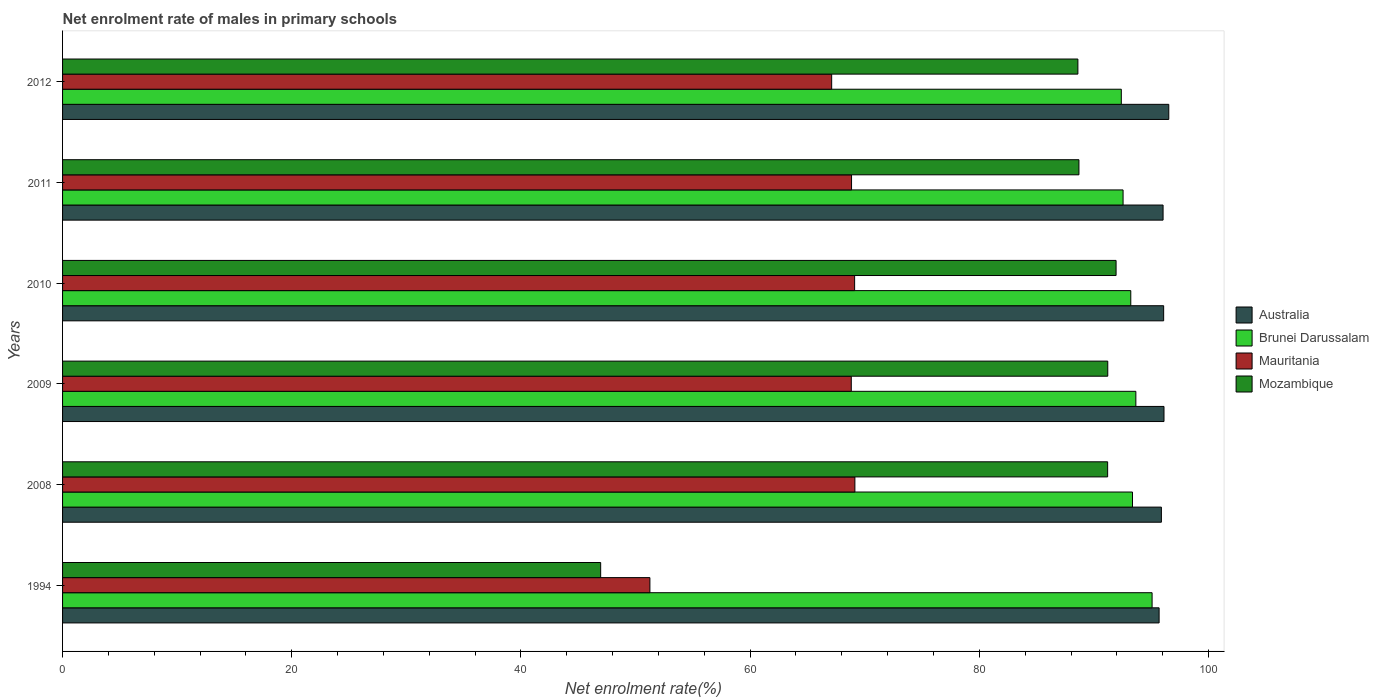How many different coloured bars are there?
Provide a succinct answer. 4. Are the number of bars on each tick of the Y-axis equal?
Make the answer very short. Yes. What is the label of the 6th group of bars from the top?
Ensure brevity in your answer.  1994. In how many cases, is the number of bars for a given year not equal to the number of legend labels?
Offer a terse response. 0. What is the net enrolment rate of males in primary schools in Mauritania in 2008?
Keep it short and to the point. 69.14. Across all years, what is the maximum net enrolment rate of males in primary schools in Mauritania?
Keep it short and to the point. 69.14. Across all years, what is the minimum net enrolment rate of males in primary schools in Australia?
Provide a succinct answer. 95.69. In which year was the net enrolment rate of males in primary schools in Mozambique minimum?
Give a very brief answer. 1994. What is the total net enrolment rate of males in primary schools in Brunei Darussalam in the graph?
Your answer should be very brief. 560.25. What is the difference between the net enrolment rate of males in primary schools in Mozambique in 2010 and that in 2012?
Your answer should be compact. 3.33. What is the difference between the net enrolment rate of males in primary schools in Brunei Darussalam in 2010 and the net enrolment rate of males in primary schools in Australia in 2009?
Provide a succinct answer. -2.9. What is the average net enrolment rate of males in primary schools in Brunei Darussalam per year?
Offer a terse response. 93.38. In the year 2009, what is the difference between the net enrolment rate of males in primary schools in Australia and net enrolment rate of males in primary schools in Brunei Darussalam?
Your answer should be very brief. 2.45. In how many years, is the net enrolment rate of males in primary schools in Mozambique greater than 4 %?
Offer a very short reply. 6. What is the ratio of the net enrolment rate of males in primary schools in Mozambique in 1994 to that in 2009?
Keep it short and to the point. 0.51. Is the net enrolment rate of males in primary schools in Brunei Darussalam in 2011 less than that in 2012?
Your answer should be compact. No. What is the difference between the highest and the second highest net enrolment rate of males in primary schools in Australia?
Your answer should be compact. 0.42. What is the difference between the highest and the lowest net enrolment rate of males in primary schools in Mozambique?
Your response must be concise. 44.98. In how many years, is the net enrolment rate of males in primary schools in Brunei Darussalam greater than the average net enrolment rate of males in primary schools in Brunei Darussalam taken over all years?
Offer a terse response. 2. Is it the case that in every year, the sum of the net enrolment rate of males in primary schools in Mauritania and net enrolment rate of males in primary schools in Mozambique is greater than the sum of net enrolment rate of males in primary schools in Australia and net enrolment rate of males in primary schools in Brunei Darussalam?
Your answer should be compact. No. Are all the bars in the graph horizontal?
Your response must be concise. Yes. How many years are there in the graph?
Offer a terse response. 6. Does the graph contain any zero values?
Provide a short and direct response. No. Does the graph contain grids?
Your answer should be very brief. No. How are the legend labels stacked?
Give a very brief answer. Vertical. What is the title of the graph?
Your answer should be very brief. Net enrolment rate of males in primary schools. What is the label or title of the X-axis?
Your answer should be very brief. Net enrolment rate(%). What is the Net enrolment rate(%) of Australia in 1994?
Offer a terse response. 95.69. What is the Net enrolment rate(%) of Brunei Darussalam in 1994?
Your answer should be very brief. 95.08. What is the Net enrolment rate(%) of Mauritania in 1994?
Provide a succinct answer. 51.25. What is the Net enrolment rate(%) of Mozambique in 1994?
Provide a short and direct response. 46.96. What is the Net enrolment rate(%) of Australia in 2008?
Your response must be concise. 95.89. What is the Net enrolment rate(%) in Brunei Darussalam in 2008?
Provide a short and direct response. 93.37. What is the Net enrolment rate(%) of Mauritania in 2008?
Your response must be concise. 69.14. What is the Net enrolment rate(%) of Mozambique in 2008?
Offer a very short reply. 91.2. What is the Net enrolment rate(%) of Australia in 2009?
Your answer should be very brief. 96.11. What is the Net enrolment rate(%) in Brunei Darussalam in 2009?
Your response must be concise. 93.66. What is the Net enrolment rate(%) of Mauritania in 2009?
Provide a succinct answer. 68.83. What is the Net enrolment rate(%) of Mozambique in 2009?
Give a very brief answer. 91.21. What is the Net enrolment rate(%) of Australia in 2010?
Your response must be concise. 96.09. What is the Net enrolment rate(%) of Brunei Darussalam in 2010?
Offer a terse response. 93.22. What is the Net enrolment rate(%) of Mauritania in 2010?
Provide a short and direct response. 69.12. What is the Net enrolment rate(%) of Mozambique in 2010?
Make the answer very short. 91.93. What is the Net enrolment rate(%) of Australia in 2011?
Make the answer very short. 96.03. What is the Net enrolment rate(%) in Brunei Darussalam in 2011?
Make the answer very short. 92.54. What is the Net enrolment rate(%) of Mauritania in 2011?
Give a very brief answer. 68.85. What is the Net enrolment rate(%) of Mozambique in 2011?
Your response must be concise. 88.69. What is the Net enrolment rate(%) of Australia in 2012?
Your answer should be very brief. 96.53. What is the Net enrolment rate(%) in Brunei Darussalam in 2012?
Offer a very short reply. 92.39. What is the Net enrolment rate(%) in Mauritania in 2012?
Your response must be concise. 67.12. What is the Net enrolment rate(%) in Mozambique in 2012?
Offer a terse response. 88.6. Across all years, what is the maximum Net enrolment rate(%) in Australia?
Give a very brief answer. 96.53. Across all years, what is the maximum Net enrolment rate(%) of Brunei Darussalam?
Your answer should be compact. 95.08. Across all years, what is the maximum Net enrolment rate(%) of Mauritania?
Keep it short and to the point. 69.14. Across all years, what is the maximum Net enrolment rate(%) in Mozambique?
Your answer should be compact. 91.93. Across all years, what is the minimum Net enrolment rate(%) of Australia?
Keep it short and to the point. 95.69. Across all years, what is the minimum Net enrolment rate(%) of Brunei Darussalam?
Offer a very short reply. 92.39. Across all years, what is the minimum Net enrolment rate(%) in Mauritania?
Provide a succinct answer. 51.25. Across all years, what is the minimum Net enrolment rate(%) in Mozambique?
Offer a terse response. 46.96. What is the total Net enrolment rate(%) in Australia in the graph?
Make the answer very short. 576.34. What is the total Net enrolment rate(%) of Brunei Darussalam in the graph?
Keep it short and to the point. 560.25. What is the total Net enrolment rate(%) of Mauritania in the graph?
Offer a very short reply. 394.3. What is the total Net enrolment rate(%) in Mozambique in the graph?
Offer a very short reply. 498.59. What is the difference between the Net enrolment rate(%) in Australia in 1994 and that in 2008?
Provide a succinct answer. -0.2. What is the difference between the Net enrolment rate(%) in Brunei Darussalam in 1994 and that in 2008?
Provide a succinct answer. 1.71. What is the difference between the Net enrolment rate(%) of Mauritania in 1994 and that in 2008?
Make the answer very short. -17.89. What is the difference between the Net enrolment rate(%) in Mozambique in 1994 and that in 2008?
Offer a very short reply. -44.24. What is the difference between the Net enrolment rate(%) of Australia in 1994 and that in 2009?
Offer a terse response. -0.43. What is the difference between the Net enrolment rate(%) of Brunei Darussalam in 1994 and that in 2009?
Your answer should be very brief. 1.42. What is the difference between the Net enrolment rate(%) in Mauritania in 1994 and that in 2009?
Give a very brief answer. -17.57. What is the difference between the Net enrolment rate(%) in Mozambique in 1994 and that in 2009?
Provide a short and direct response. -44.25. What is the difference between the Net enrolment rate(%) in Australia in 1994 and that in 2010?
Give a very brief answer. -0.4. What is the difference between the Net enrolment rate(%) in Brunei Darussalam in 1994 and that in 2010?
Make the answer very short. 1.86. What is the difference between the Net enrolment rate(%) in Mauritania in 1994 and that in 2010?
Offer a very short reply. -17.86. What is the difference between the Net enrolment rate(%) in Mozambique in 1994 and that in 2010?
Make the answer very short. -44.98. What is the difference between the Net enrolment rate(%) in Australia in 1994 and that in 2011?
Provide a succinct answer. -0.35. What is the difference between the Net enrolment rate(%) of Brunei Darussalam in 1994 and that in 2011?
Your answer should be compact. 2.53. What is the difference between the Net enrolment rate(%) in Mauritania in 1994 and that in 2011?
Make the answer very short. -17.6. What is the difference between the Net enrolment rate(%) of Mozambique in 1994 and that in 2011?
Keep it short and to the point. -41.73. What is the difference between the Net enrolment rate(%) of Australia in 1994 and that in 2012?
Provide a short and direct response. -0.84. What is the difference between the Net enrolment rate(%) in Brunei Darussalam in 1994 and that in 2012?
Ensure brevity in your answer.  2.69. What is the difference between the Net enrolment rate(%) of Mauritania in 1994 and that in 2012?
Offer a very short reply. -15.86. What is the difference between the Net enrolment rate(%) in Mozambique in 1994 and that in 2012?
Offer a very short reply. -41.64. What is the difference between the Net enrolment rate(%) in Australia in 2008 and that in 2009?
Offer a very short reply. -0.23. What is the difference between the Net enrolment rate(%) of Brunei Darussalam in 2008 and that in 2009?
Provide a succinct answer. -0.29. What is the difference between the Net enrolment rate(%) of Mauritania in 2008 and that in 2009?
Your response must be concise. 0.31. What is the difference between the Net enrolment rate(%) of Mozambique in 2008 and that in 2009?
Your response must be concise. -0.01. What is the difference between the Net enrolment rate(%) of Australia in 2008 and that in 2010?
Ensure brevity in your answer.  -0.2. What is the difference between the Net enrolment rate(%) of Brunei Darussalam in 2008 and that in 2010?
Provide a succinct answer. 0.15. What is the difference between the Net enrolment rate(%) in Mauritania in 2008 and that in 2010?
Make the answer very short. 0.02. What is the difference between the Net enrolment rate(%) in Mozambique in 2008 and that in 2010?
Offer a very short reply. -0.74. What is the difference between the Net enrolment rate(%) of Australia in 2008 and that in 2011?
Offer a very short reply. -0.15. What is the difference between the Net enrolment rate(%) of Brunei Darussalam in 2008 and that in 2011?
Ensure brevity in your answer.  0.82. What is the difference between the Net enrolment rate(%) of Mauritania in 2008 and that in 2011?
Offer a terse response. 0.29. What is the difference between the Net enrolment rate(%) of Mozambique in 2008 and that in 2011?
Your answer should be compact. 2.51. What is the difference between the Net enrolment rate(%) in Australia in 2008 and that in 2012?
Provide a succinct answer. -0.64. What is the difference between the Net enrolment rate(%) of Brunei Darussalam in 2008 and that in 2012?
Your answer should be compact. 0.98. What is the difference between the Net enrolment rate(%) of Mauritania in 2008 and that in 2012?
Give a very brief answer. 2.03. What is the difference between the Net enrolment rate(%) of Mozambique in 2008 and that in 2012?
Your response must be concise. 2.6. What is the difference between the Net enrolment rate(%) of Australia in 2009 and that in 2010?
Your answer should be compact. 0.03. What is the difference between the Net enrolment rate(%) in Brunei Darussalam in 2009 and that in 2010?
Your answer should be very brief. 0.44. What is the difference between the Net enrolment rate(%) in Mauritania in 2009 and that in 2010?
Ensure brevity in your answer.  -0.29. What is the difference between the Net enrolment rate(%) of Mozambique in 2009 and that in 2010?
Your answer should be compact. -0.73. What is the difference between the Net enrolment rate(%) of Australia in 2009 and that in 2011?
Your answer should be compact. 0.08. What is the difference between the Net enrolment rate(%) of Brunei Darussalam in 2009 and that in 2011?
Provide a succinct answer. 1.12. What is the difference between the Net enrolment rate(%) in Mauritania in 2009 and that in 2011?
Ensure brevity in your answer.  -0.02. What is the difference between the Net enrolment rate(%) in Mozambique in 2009 and that in 2011?
Provide a short and direct response. 2.52. What is the difference between the Net enrolment rate(%) of Australia in 2009 and that in 2012?
Keep it short and to the point. -0.42. What is the difference between the Net enrolment rate(%) of Brunei Darussalam in 2009 and that in 2012?
Offer a very short reply. 1.27. What is the difference between the Net enrolment rate(%) of Mauritania in 2009 and that in 2012?
Provide a succinct answer. 1.71. What is the difference between the Net enrolment rate(%) in Mozambique in 2009 and that in 2012?
Give a very brief answer. 2.61. What is the difference between the Net enrolment rate(%) in Australia in 2010 and that in 2011?
Your response must be concise. 0.05. What is the difference between the Net enrolment rate(%) in Brunei Darussalam in 2010 and that in 2011?
Offer a very short reply. 0.67. What is the difference between the Net enrolment rate(%) of Mauritania in 2010 and that in 2011?
Make the answer very short. 0.27. What is the difference between the Net enrolment rate(%) of Mozambique in 2010 and that in 2011?
Give a very brief answer. 3.24. What is the difference between the Net enrolment rate(%) in Australia in 2010 and that in 2012?
Provide a short and direct response. -0.45. What is the difference between the Net enrolment rate(%) in Brunei Darussalam in 2010 and that in 2012?
Your answer should be very brief. 0.83. What is the difference between the Net enrolment rate(%) of Mauritania in 2010 and that in 2012?
Give a very brief answer. 2. What is the difference between the Net enrolment rate(%) in Mozambique in 2010 and that in 2012?
Offer a very short reply. 3.33. What is the difference between the Net enrolment rate(%) of Australia in 2011 and that in 2012?
Give a very brief answer. -0.5. What is the difference between the Net enrolment rate(%) of Brunei Darussalam in 2011 and that in 2012?
Your answer should be compact. 0.15. What is the difference between the Net enrolment rate(%) of Mauritania in 2011 and that in 2012?
Offer a very short reply. 1.73. What is the difference between the Net enrolment rate(%) of Mozambique in 2011 and that in 2012?
Provide a succinct answer. 0.09. What is the difference between the Net enrolment rate(%) of Australia in 1994 and the Net enrolment rate(%) of Brunei Darussalam in 2008?
Keep it short and to the point. 2.32. What is the difference between the Net enrolment rate(%) of Australia in 1994 and the Net enrolment rate(%) of Mauritania in 2008?
Give a very brief answer. 26.55. What is the difference between the Net enrolment rate(%) of Australia in 1994 and the Net enrolment rate(%) of Mozambique in 2008?
Give a very brief answer. 4.49. What is the difference between the Net enrolment rate(%) in Brunei Darussalam in 1994 and the Net enrolment rate(%) in Mauritania in 2008?
Keep it short and to the point. 25.94. What is the difference between the Net enrolment rate(%) in Brunei Darussalam in 1994 and the Net enrolment rate(%) in Mozambique in 2008?
Offer a very short reply. 3.88. What is the difference between the Net enrolment rate(%) of Mauritania in 1994 and the Net enrolment rate(%) of Mozambique in 2008?
Ensure brevity in your answer.  -39.94. What is the difference between the Net enrolment rate(%) of Australia in 1994 and the Net enrolment rate(%) of Brunei Darussalam in 2009?
Ensure brevity in your answer.  2.03. What is the difference between the Net enrolment rate(%) of Australia in 1994 and the Net enrolment rate(%) of Mauritania in 2009?
Give a very brief answer. 26.86. What is the difference between the Net enrolment rate(%) of Australia in 1994 and the Net enrolment rate(%) of Mozambique in 2009?
Offer a very short reply. 4.48. What is the difference between the Net enrolment rate(%) in Brunei Darussalam in 1994 and the Net enrolment rate(%) in Mauritania in 2009?
Make the answer very short. 26.25. What is the difference between the Net enrolment rate(%) in Brunei Darussalam in 1994 and the Net enrolment rate(%) in Mozambique in 2009?
Keep it short and to the point. 3.87. What is the difference between the Net enrolment rate(%) of Mauritania in 1994 and the Net enrolment rate(%) of Mozambique in 2009?
Provide a short and direct response. -39.95. What is the difference between the Net enrolment rate(%) in Australia in 1994 and the Net enrolment rate(%) in Brunei Darussalam in 2010?
Provide a short and direct response. 2.47. What is the difference between the Net enrolment rate(%) of Australia in 1994 and the Net enrolment rate(%) of Mauritania in 2010?
Provide a short and direct response. 26.57. What is the difference between the Net enrolment rate(%) of Australia in 1994 and the Net enrolment rate(%) of Mozambique in 2010?
Ensure brevity in your answer.  3.76. What is the difference between the Net enrolment rate(%) of Brunei Darussalam in 1994 and the Net enrolment rate(%) of Mauritania in 2010?
Your response must be concise. 25.96. What is the difference between the Net enrolment rate(%) in Brunei Darussalam in 1994 and the Net enrolment rate(%) in Mozambique in 2010?
Ensure brevity in your answer.  3.14. What is the difference between the Net enrolment rate(%) in Mauritania in 1994 and the Net enrolment rate(%) in Mozambique in 2010?
Offer a terse response. -40.68. What is the difference between the Net enrolment rate(%) in Australia in 1994 and the Net enrolment rate(%) in Brunei Darussalam in 2011?
Ensure brevity in your answer.  3.15. What is the difference between the Net enrolment rate(%) of Australia in 1994 and the Net enrolment rate(%) of Mauritania in 2011?
Give a very brief answer. 26.84. What is the difference between the Net enrolment rate(%) of Australia in 1994 and the Net enrolment rate(%) of Mozambique in 2011?
Offer a very short reply. 7. What is the difference between the Net enrolment rate(%) in Brunei Darussalam in 1994 and the Net enrolment rate(%) in Mauritania in 2011?
Your response must be concise. 26.23. What is the difference between the Net enrolment rate(%) in Brunei Darussalam in 1994 and the Net enrolment rate(%) in Mozambique in 2011?
Your answer should be compact. 6.38. What is the difference between the Net enrolment rate(%) of Mauritania in 1994 and the Net enrolment rate(%) of Mozambique in 2011?
Your answer should be very brief. -37.44. What is the difference between the Net enrolment rate(%) in Australia in 1994 and the Net enrolment rate(%) in Brunei Darussalam in 2012?
Give a very brief answer. 3.3. What is the difference between the Net enrolment rate(%) in Australia in 1994 and the Net enrolment rate(%) in Mauritania in 2012?
Your answer should be compact. 28.57. What is the difference between the Net enrolment rate(%) of Australia in 1994 and the Net enrolment rate(%) of Mozambique in 2012?
Your answer should be compact. 7.09. What is the difference between the Net enrolment rate(%) of Brunei Darussalam in 1994 and the Net enrolment rate(%) of Mauritania in 2012?
Offer a very short reply. 27.96. What is the difference between the Net enrolment rate(%) of Brunei Darussalam in 1994 and the Net enrolment rate(%) of Mozambique in 2012?
Give a very brief answer. 6.47. What is the difference between the Net enrolment rate(%) of Mauritania in 1994 and the Net enrolment rate(%) of Mozambique in 2012?
Offer a terse response. -37.35. What is the difference between the Net enrolment rate(%) of Australia in 2008 and the Net enrolment rate(%) of Brunei Darussalam in 2009?
Provide a short and direct response. 2.23. What is the difference between the Net enrolment rate(%) in Australia in 2008 and the Net enrolment rate(%) in Mauritania in 2009?
Provide a succinct answer. 27.06. What is the difference between the Net enrolment rate(%) in Australia in 2008 and the Net enrolment rate(%) in Mozambique in 2009?
Provide a short and direct response. 4.68. What is the difference between the Net enrolment rate(%) of Brunei Darussalam in 2008 and the Net enrolment rate(%) of Mauritania in 2009?
Offer a very short reply. 24.54. What is the difference between the Net enrolment rate(%) in Brunei Darussalam in 2008 and the Net enrolment rate(%) in Mozambique in 2009?
Make the answer very short. 2.16. What is the difference between the Net enrolment rate(%) of Mauritania in 2008 and the Net enrolment rate(%) of Mozambique in 2009?
Ensure brevity in your answer.  -22.07. What is the difference between the Net enrolment rate(%) of Australia in 2008 and the Net enrolment rate(%) of Brunei Darussalam in 2010?
Provide a short and direct response. 2.67. What is the difference between the Net enrolment rate(%) of Australia in 2008 and the Net enrolment rate(%) of Mauritania in 2010?
Your response must be concise. 26.77. What is the difference between the Net enrolment rate(%) in Australia in 2008 and the Net enrolment rate(%) in Mozambique in 2010?
Ensure brevity in your answer.  3.95. What is the difference between the Net enrolment rate(%) of Brunei Darussalam in 2008 and the Net enrolment rate(%) of Mauritania in 2010?
Offer a very short reply. 24.25. What is the difference between the Net enrolment rate(%) of Brunei Darussalam in 2008 and the Net enrolment rate(%) of Mozambique in 2010?
Ensure brevity in your answer.  1.43. What is the difference between the Net enrolment rate(%) in Mauritania in 2008 and the Net enrolment rate(%) in Mozambique in 2010?
Provide a short and direct response. -22.79. What is the difference between the Net enrolment rate(%) in Australia in 2008 and the Net enrolment rate(%) in Brunei Darussalam in 2011?
Your answer should be compact. 3.34. What is the difference between the Net enrolment rate(%) in Australia in 2008 and the Net enrolment rate(%) in Mauritania in 2011?
Your answer should be compact. 27.04. What is the difference between the Net enrolment rate(%) in Australia in 2008 and the Net enrolment rate(%) in Mozambique in 2011?
Make the answer very short. 7.2. What is the difference between the Net enrolment rate(%) in Brunei Darussalam in 2008 and the Net enrolment rate(%) in Mauritania in 2011?
Offer a terse response. 24.52. What is the difference between the Net enrolment rate(%) of Brunei Darussalam in 2008 and the Net enrolment rate(%) of Mozambique in 2011?
Give a very brief answer. 4.68. What is the difference between the Net enrolment rate(%) in Mauritania in 2008 and the Net enrolment rate(%) in Mozambique in 2011?
Keep it short and to the point. -19.55. What is the difference between the Net enrolment rate(%) of Australia in 2008 and the Net enrolment rate(%) of Brunei Darussalam in 2012?
Offer a terse response. 3.5. What is the difference between the Net enrolment rate(%) in Australia in 2008 and the Net enrolment rate(%) in Mauritania in 2012?
Offer a very short reply. 28.77. What is the difference between the Net enrolment rate(%) of Australia in 2008 and the Net enrolment rate(%) of Mozambique in 2012?
Keep it short and to the point. 7.29. What is the difference between the Net enrolment rate(%) of Brunei Darussalam in 2008 and the Net enrolment rate(%) of Mauritania in 2012?
Keep it short and to the point. 26.25. What is the difference between the Net enrolment rate(%) of Brunei Darussalam in 2008 and the Net enrolment rate(%) of Mozambique in 2012?
Provide a succinct answer. 4.77. What is the difference between the Net enrolment rate(%) in Mauritania in 2008 and the Net enrolment rate(%) in Mozambique in 2012?
Keep it short and to the point. -19.46. What is the difference between the Net enrolment rate(%) of Australia in 2009 and the Net enrolment rate(%) of Brunei Darussalam in 2010?
Your response must be concise. 2.9. What is the difference between the Net enrolment rate(%) of Australia in 2009 and the Net enrolment rate(%) of Mauritania in 2010?
Provide a succinct answer. 27. What is the difference between the Net enrolment rate(%) in Australia in 2009 and the Net enrolment rate(%) in Mozambique in 2010?
Your answer should be compact. 4.18. What is the difference between the Net enrolment rate(%) in Brunei Darussalam in 2009 and the Net enrolment rate(%) in Mauritania in 2010?
Offer a very short reply. 24.54. What is the difference between the Net enrolment rate(%) of Brunei Darussalam in 2009 and the Net enrolment rate(%) of Mozambique in 2010?
Your answer should be compact. 1.73. What is the difference between the Net enrolment rate(%) in Mauritania in 2009 and the Net enrolment rate(%) in Mozambique in 2010?
Provide a succinct answer. -23.11. What is the difference between the Net enrolment rate(%) of Australia in 2009 and the Net enrolment rate(%) of Brunei Darussalam in 2011?
Offer a terse response. 3.57. What is the difference between the Net enrolment rate(%) in Australia in 2009 and the Net enrolment rate(%) in Mauritania in 2011?
Offer a very short reply. 27.27. What is the difference between the Net enrolment rate(%) in Australia in 2009 and the Net enrolment rate(%) in Mozambique in 2011?
Make the answer very short. 7.42. What is the difference between the Net enrolment rate(%) of Brunei Darussalam in 2009 and the Net enrolment rate(%) of Mauritania in 2011?
Your answer should be compact. 24.81. What is the difference between the Net enrolment rate(%) of Brunei Darussalam in 2009 and the Net enrolment rate(%) of Mozambique in 2011?
Offer a terse response. 4.97. What is the difference between the Net enrolment rate(%) in Mauritania in 2009 and the Net enrolment rate(%) in Mozambique in 2011?
Make the answer very short. -19.87. What is the difference between the Net enrolment rate(%) in Australia in 2009 and the Net enrolment rate(%) in Brunei Darussalam in 2012?
Offer a very short reply. 3.72. What is the difference between the Net enrolment rate(%) of Australia in 2009 and the Net enrolment rate(%) of Mauritania in 2012?
Give a very brief answer. 29. What is the difference between the Net enrolment rate(%) of Australia in 2009 and the Net enrolment rate(%) of Mozambique in 2012?
Keep it short and to the point. 7.51. What is the difference between the Net enrolment rate(%) in Brunei Darussalam in 2009 and the Net enrolment rate(%) in Mauritania in 2012?
Your response must be concise. 26.54. What is the difference between the Net enrolment rate(%) of Brunei Darussalam in 2009 and the Net enrolment rate(%) of Mozambique in 2012?
Offer a very short reply. 5.06. What is the difference between the Net enrolment rate(%) of Mauritania in 2009 and the Net enrolment rate(%) of Mozambique in 2012?
Offer a very short reply. -19.77. What is the difference between the Net enrolment rate(%) in Australia in 2010 and the Net enrolment rate(%) in Brunei Darussalam in 2011?
Make the answer very short. 3.54. What is the difference between the Net enrolment rate(%) in Australia in 2010 and the Net enrolment rate(%) in Mauritania in 2011?
Provide a short and direct response. 27.24. What is the difference between the Net enrolment rate(%) in Australia in 2010 and the Net enrolment rate(%) in Mozambique in 2011?
Offer a terse response. 7.39. What is the difference between the Net enrolment rate(%) of Brunei Darussalam in 2010 and the Net enrolment rate(%) of Mauritania in 2011?
Your answer should be very brief. 24.37. What is the difference between the Net enrolment rate(%) of Brunei Darussalam in 2010 and the Net enrolment rate(%) of Mozambique in 2011?
Keep it short and to the point. 4.52. What is the difference between the Net enrolment rate(%) in Mauritania in 2010 and the Net enrolment rate(%) in Mozambique in 2011?
Keep it short and to the point. -19.57. What is the difference between the Net enrolment rate(%) in Australia in 2010 and the Net enrolment rate(%) in Brunei Darussalam in 2012?
Provide a short and direct response. 3.69. What is the difference between the Net enrolment rate(%) of Australia in 2010 and the Net enrolment rate(%) of Mauritania in 2012?
Your response must be concise. 28.97. What is the difference between the Net enrolment rate(%) of Australia in 2010 and the Net enrolment rate(%) of Mozambique in 2012?
Make the answer very short. 7.48. What is the difference between the Net enrolment rate(%) of Brunei Darussalam in 2010 and the Net enrolment rate(%) of Mauritania in 2012?
Provide a succinct answer. 26.1. What is the difference between the Net enrolment rate(%) in Brunei Darussalam in 2010 and the Net enrolment rate(%) in Mozambique in 2012?
Give a very brief answer. 4.62. What is the difference between the Net enrolment rate(%) in Mauritania in 2010 and the Net enrolment rate(%) in Mozambique in 2012?
Keep it short and to the point. -19.48. What is the difference between the Net enrolment rate(%) in Australia in 2011 and the Net enrolment rate(%) in Brunei Darussalam in 2012?
Your answer should be compact. 3.64. What is the difference between the Net enrolment rate(%) of Australia in 2011 and the Net enrolment rate(%) of Mauritania in 2012?
Ensure brevity in your answer.  28.92. What is the difference between the Net enrolment rate(%) of Australia in 2011 and the Net enrolment rate(%) of Mozambique in 2012?
Your answer should be compact. 7.43. What is the difference between the Net enrolment rate(%) in Brunei Darussalam in 2011 and the Net enrolment rate(%) in Mauritania in 2012?
Give a very brief answer. 25.43. What is the difference between the Net enrolment rate(%) of Brunei Darussalam in 2011 and the Net enrolment rate(%) of Mozambique in 2012?
Your answer should be compact. 3.94. What is the difference between the Net enrolment rate(%) in Mauritania in 2011 and the Net enrolment rate(%) in Mozambique in 2012?
Your response must be concise. -19.75. What is the average Net enrolment rate(%) of Australia per year?
Give a very brief answer. 96.06. What is the average Net enrolment rate(%) of Brunei Darussalam per year?
Provide a short and direct response. 93.38. What is the average Net enrolment rate(%) in Mauritania per year?
Ensure brevity in your answer.  65.72. What is the average Net enrolment rate(%) of Mozambique per year?
Your response must be concise. 83.1. In the year 1994, what is the difference between the Net enrolment rate(%) of Australia and Net enrolment rate(%) of Brunei Darussalam?
Make the answer very short. 0.61. In the year 1994, what is the difference between the Net enrolment rate(%) in Australia and Net enrolment rate(%) in Mauritania?
Give a very brief answer. 44.43. In the year 1994, what is the difference between the Net enrolment rate(%) in Australia and Net enrolment rate(%) in Mozambique?
Provide a short and direct response. 48.73. In the year 1994, what is the difference between the Net enrolment rate(%) of Brunei Darussalam and Net enrolment rate(%) of Mauritania?
Ensure brevity in your answer.  43.82. In the year 1994, what is the difference between the Net enrolment rate(%) of Brunei Darussalam and Net enrolment rate(%) of Mozambique?
Provide a short and direct response. 48.12. In the year 1994, what is the difference between the Net enrolment rate(%) of Mauritania and Net enrolment rate(%) of Mozambique?
Offer a terse response. 4.3. In the year 2008, what is the difference between the Net enrolment rate(%) in Australia and Net enrolment rate(%) in Brunei Darussalam?
Offer a terse response. 2.52. In the year 2008, what is the difference between the Net enrolment rate(%) in Australia and Net enrolment rate(%) in Mauritania?
Keep it short and to the point. 26.75. In the year 2008, what is the difference between the Net enrolment rate(%) in Australia and Net enrolment rate(%) in Mozambique?
Ensure brevity in your answer.  4.69. In the year 2008, what is the difference between the Net enrolment rate(%) of Brunei Darussalam and Net enrolment rate(%) of Mauritania?
Offer a very short reply. 24.23. In the year 2008, what is the difference between the Net enrolment rate(%) in Brunei Darussalam and Net enrolment rate(%) in Mozambique?
Your answer should be compact. 2.17. In the year 2008, what is the difference between the Net enrolment rate(%) of Mauritania and Net enrolment rate(%) of Mozambique?
Give a very brief answer. -22.06. In the year 2009, what is the difference between the Net enrolment rate(%) in Australia and Net enrolment rate(%) in Brunei Darussalam?
Your answer should be very brief. 2.45. In the year 2009, what is the difference between the Net enrolment rate(%) in Australia and Net enrolment rate(%) in Mauritania?
Provide a short and direct response. 27.29. In the year 2009, what is the difference between the Net enrolment rate(%) in Australia and Net enrolment rate(%) in Mozambique?
Make the answer very short. 4.91. In the year 2009, what is the difference between the Net enrolment rate(%) of Brunei Darussalam and Net enrolment rate(%) of Mauritania?
Provide a succinct answer. 24.83. In the year 2009, what is the difference between the Net enrolment rate(%) of Brunei Darussalam and Net enrolment rate(%) of Mozambique?
Ensure brevity in your answer.  2.45. In the year 2009, what is the difference between the Net enrolment rate(%) in Mauritania and Net enrolment rate(%) in Mozambique?
Offer a very short reply. -22.38. In the year 2010, what is the difference between the Net enrolment rate(%) of Australia and Net enrolment rate(%) of Brunei Darussalam?
Provide a succinct answer. 2.87. In the year 2010, what is the difference between the Net enrolment rate(%) in Australia and Net enrolment rate(%) in Mauritania?
Your answer should be compact. 26.97. In the year 2010, what is the difference between the Net enrolment rate(%) of Australia and Net enrolment rate(%) of Mozambique?
Offer a very short reply. 4.15. In the year 2010, what is the difference between the Net enrolment rate(%) in Brunei Darussalam and Net enrolment rate(%) in Mauritania?
Your answer should be compact. 24.1. In the year 2010, what is the difference between the Net enrolment rate(%) of Brunei Darussalam and Net enrolment rate(%) of Mozambique?
Provide a succinct answer. 1.28. In the year 2010, what is the difference between the Net enrolment rate(%) in Mauritania and Net enrolment rate(%) in Mozambique?
Offer a terse response. -22.82. In the year 2011, what is the difference between the Net enrolment rate(%) in Australia and Net enrolment rate(%) in Brunei Darussalam?
Keep it short and to the point. 3.49. In the year 2011, what is the difference between the Net enrolment rate(%) in Australia and Net enrolment rate(%) in Mauritania?
Offer a very short reply. 27.18. In the year 2011, what is the difference between the Net enrolment rate(%) of Australia and Net enrolment rate(%) of Mozambique?
Your response must be concise. 7.34. In the year 2011, what is the difference between the Net enrolment rate(%) in Brunei Darussalam and Net enrolment rate(%) in Mauritania?
Your answer should be very brief. 23.69. In the year 2011, what is the difference between the Net enrolment rate(%) of Brunei Darussalam and Net enrolment rate(%) of Mozambique?
Offer a very short reply. 3.85. In the year 2011, what is the difference between the Net enrolment rate(%) of Mauritania and Net enrolment rate(%) of Mozambique?
Offer a terse response. -19.84. In the year 2012, what is the difference between the Net enrolment rate(%) in Australia and Net enrolment rate(%) in Brunei Darussalam?
Offer a very short reply. 4.14. In the year 2012, what is the difference between the Net enrolment rate(%) of Australia and Net enrolment rate(%) of Mauritania?
Your answer should be very brief. 29.42. In the year 2012, what is the difference between the Net enrolment rate(%) of Australia and Net enrolment rate(%) of Mozambique?
Your answer should be compact. 7.93. In the year 2012, what is the difference between the Net enrolment rate(%) of Brunei Darussalam and Net enrolment rate(%) of Mauritania?
Ensure brevity in your answer.  25.28. In the year 2012, what is the difference between the Net enrolment rate(%) of Brunei Darussalam and Net enrolment rate(%) of Mozambique?
Keep it short and to the point. 3.79. In the year 2012, what is the difference between the Net enrolment rate(%) in Mauritania and Net enrolment rate(%) in Mozambique?
Your answer should be very brief. -21.49. What is the ratio of the Net enrolment rate(%) of Brunei Darussalam in 1994 to that in 2008?
Give a very brief answer. 1.02. What is the ratio of the Net enrolment rate(%) of Mauritania in 1994 to that in 2008?
Offer a very short reply. 0.74. What is the ratio of the Net enrolment rate(%) in Mozambique in 1994 to that in 2008?
Offer a terse response. 0.51. What is the ratio of the Net enrolment rate(%) in Brunei Darussalam in 1994 to that in 2009?
Keep it short and to the point. 1.02. What is the ratio of the Net enrolment rate(%) of Mauritania in 1994 to that in 2009?
Your response must be concise. 0.74. What is the ratio of the Net enrolment rate(%) of Mozambique in 1994 to that in 2009?
Provide a short and direct response. 0.51. What is the ratio of the Net enrolment rate(%) of Brunei Darussalam in 1994 to that in 2010?
Offer a terse response. 1.02. What is the ratio of the Net enrolment rate(%) in Mauritania in 1994 to that in 2010?
Offer a terse response. 0.74. What is the ratio of the Net enrolment rate(%) in Mozambique in 1994 to that in 2010?
Your response must be concise. 0.51. What is the ratio of the Net enrolment rate(%) of Brunei Darussalam in 1994 to that in 2011?
Your answer should be very brief. 1.03. What is the ratio of the Net enrolment rate(%) in Mauritania in 1994 to that in 2011?
Keep it short and to the point. 0.74. What is the ratio of the Net enrolment rate(%) in Mozambique in 1994 to that in 2011?
Provide a succinct answer. 0.53. What is the ratio of the Net enrolment rate(%) of Australia in 1994 to that in 2012?
Make the answer very short. 0.99. What is the ratio of the Net enrolment rate(%) of Brunei Darussalam in 1994 to that in 2012?
Ensure brevity in your answer.  1.03. What is the ratio of the Net enrolment rate(%) in Mauritania in 1994 to that in 2012?
Your answer should be very brief. 0.76. What is the ratio of the Net enrolment rate(%) in Mozambique in 1994 to that in 2012?
Your answer should be compact. 0.53. What is the ratio of the Net enrolment rate(%) of Australia in 2008 to that in 2009?
Your answer should be very brief. 1. What is the ratio of the Net enrolment rate(%) of Mozambique in 2008 to that in 2009?
Ensure brevity in your answer.  1. What is the ratio of the Net enrolment rate(%) of Australia in 2008 to that in 2010?
Your answer should be compact. 1. What is the ratio of the Net enrolment rate(%) of Brunei Darussalam in 2008 to that in 2010?
Offer a very short reply. 1. What is the ratio of the Net enrolment rate(%) of Mozambique in 2008 to that in 2010?
Give a very brief answer. 0.99. What is the ratio of the Net enrolment rate(%) in Brunei Darussalam in 2008 to that in 2011?
Make the answer very short. 1.01. What is the ratio of the Net enrolment rate(%) in Mauritania in 2008 to that in 2011?
Offer a terse response. 1. What is the ratio of the Net enrolment rate(%) in Mozambique in 2008 to that in 2011?
Your answer should be very brief. 1.03. What is the ratio of the Net enrolment rate(%) in Australia in 2008 to that in 2012?
Provide a short and direct response. 0.99. What is the ratio of the Net enrolment rate(%) in Brunei Darussalam in 2008 to that in 2012?
Ensure brevity in your answer.  1.01. What is the ratio of the Net enrolment rate(%) in Mauritania in 2008 to that in 2012?
Your answer should be very brief. 1.03. What is the ratio of the Net enrolment rate(%) in Mozambique in 2008 to that in 2012?
Offer a terse response. 1.03. What is the ratio of the Net enrolment rate(%) of Brunei Darussalam in 2009 to that in 2011?
Provide a short and direct response. 1.01. What is the ratio of the Net enrolment rate(%) in Mauritania in 2009 to that in 2011?
Offer a very short reply. 1. What is the ratio of the Net enrolment rate(%) in Mozambique in 2009 to that in 2011?
Your answer should be compact. 1.03. What is the ratio of the Net enrolment rate(%) of Brunei Darussalam in 2009 to that in 2012?
Make the answer very short. 1.01. What is the ratio of the Net enrolment rate(%) of Mauritania in 2009 to that in 2012?
Your response must be concise. 1.03. What is the ratio of the Net enrolment rate(%) of Mozambique in 2009 to that in 2012?
Your answer should be very brief. 1.03. What is the ratio of the Net enrolment rate(%) in Australia in 2010 to that in 2011?
Provide a short and direct response. 1. What is the ratio of the Net enrolment rate(%) of Brunei Darussalam in 2010 to that in 2011?
Offer a terse response. 1.01. What is the ratio of the Net enrolment rate(%) in Mauritania in 2010 to that in 2011?
Ensure brevity in your answer.  1. What is the ratio of the Net enrolment rate(%) of Mozambique in 2010 to that in 2011?
Make the answer very short. 1.04. What is the ratio of the Net enrolment rate(%) in Australia in 2010 to that in 2012?
Keep it short and to the point. 1. What is the ratio of the Net enrolment rate(%) of Brunei Darussalam in 2010 to that in 2012?
Your response must be concise. 1.01. What is the ratio of the Net enrolment rate(%) of Mauritania in 2010 to that in 2012?
Your response must be concise. 1.03. What is the ratio of the Net enrolment rate(%) of Mozambique in 2010 to that in 2012?
Provide a short and direct response. 1.04. What is the ratio of the Net enrolment rate(%) of Australia in 2011 to that in 2012?
Provide a short and direct response. 0.99. What is the ratio of the Net enrolment rate(%) of Brunei Darussalam in 2011 to that in 2012?
Keep it short and to the point. 1. What is the ratio of the Net enrolment rate(%) in Mauritania in 2011 to that in 2012?
Offer a terse response. 1.03. What is the ratio of the Net enrolment rate(%) in Mozambique in 2011 to that in 2012?
Your response must be concise. 1. What is the difference between the highest and the second highest Net enrolment rate(%) of Australia?
Ensure brevity in your answer.  0.42. What is the difference between the highest and the second highest Net enrolment rate(%) of Brunei Darussalam?
Offer a terse response. 1.42. What is the difference between the highest and the second highest Net enrolment rate(%) in Mauritania?
Offer a terse response. 0.02. What is the difference between the highest and the second highest Net enrolment rate(%) in Mozambique?
Offer a terse response. 0.73. What is the difference between the highest and the lowest Net enrolment rate(%) in Australia?
Provide a short and direct response. 0.84. What is the difference between the highest and the lowest Net enrolment rate(%) of Brunei Darussalam?
Make the answer very short. 2.69. What is the difference between the highest and the lowest Net enrolment rate(%) of Mauritania?
Ensure brevity in your answer.  17.89. What is the difference between the highest and the lowest Net enrolment rate(%) of Mozambique?
Give a very brief answer. 44.98. 